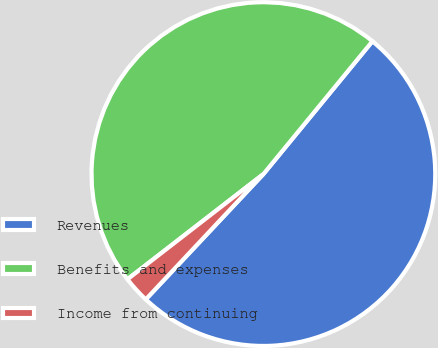Convert chart. <chart><loc_0><loc_0><loc_500><loc_500><pie_chart><fcel>Revenues<fcel>Benefits and expenses<fcel>Income from continuing<nl><fcel>51.06%<fcel>46.42%<fcel>2.52%<nl></chart> 